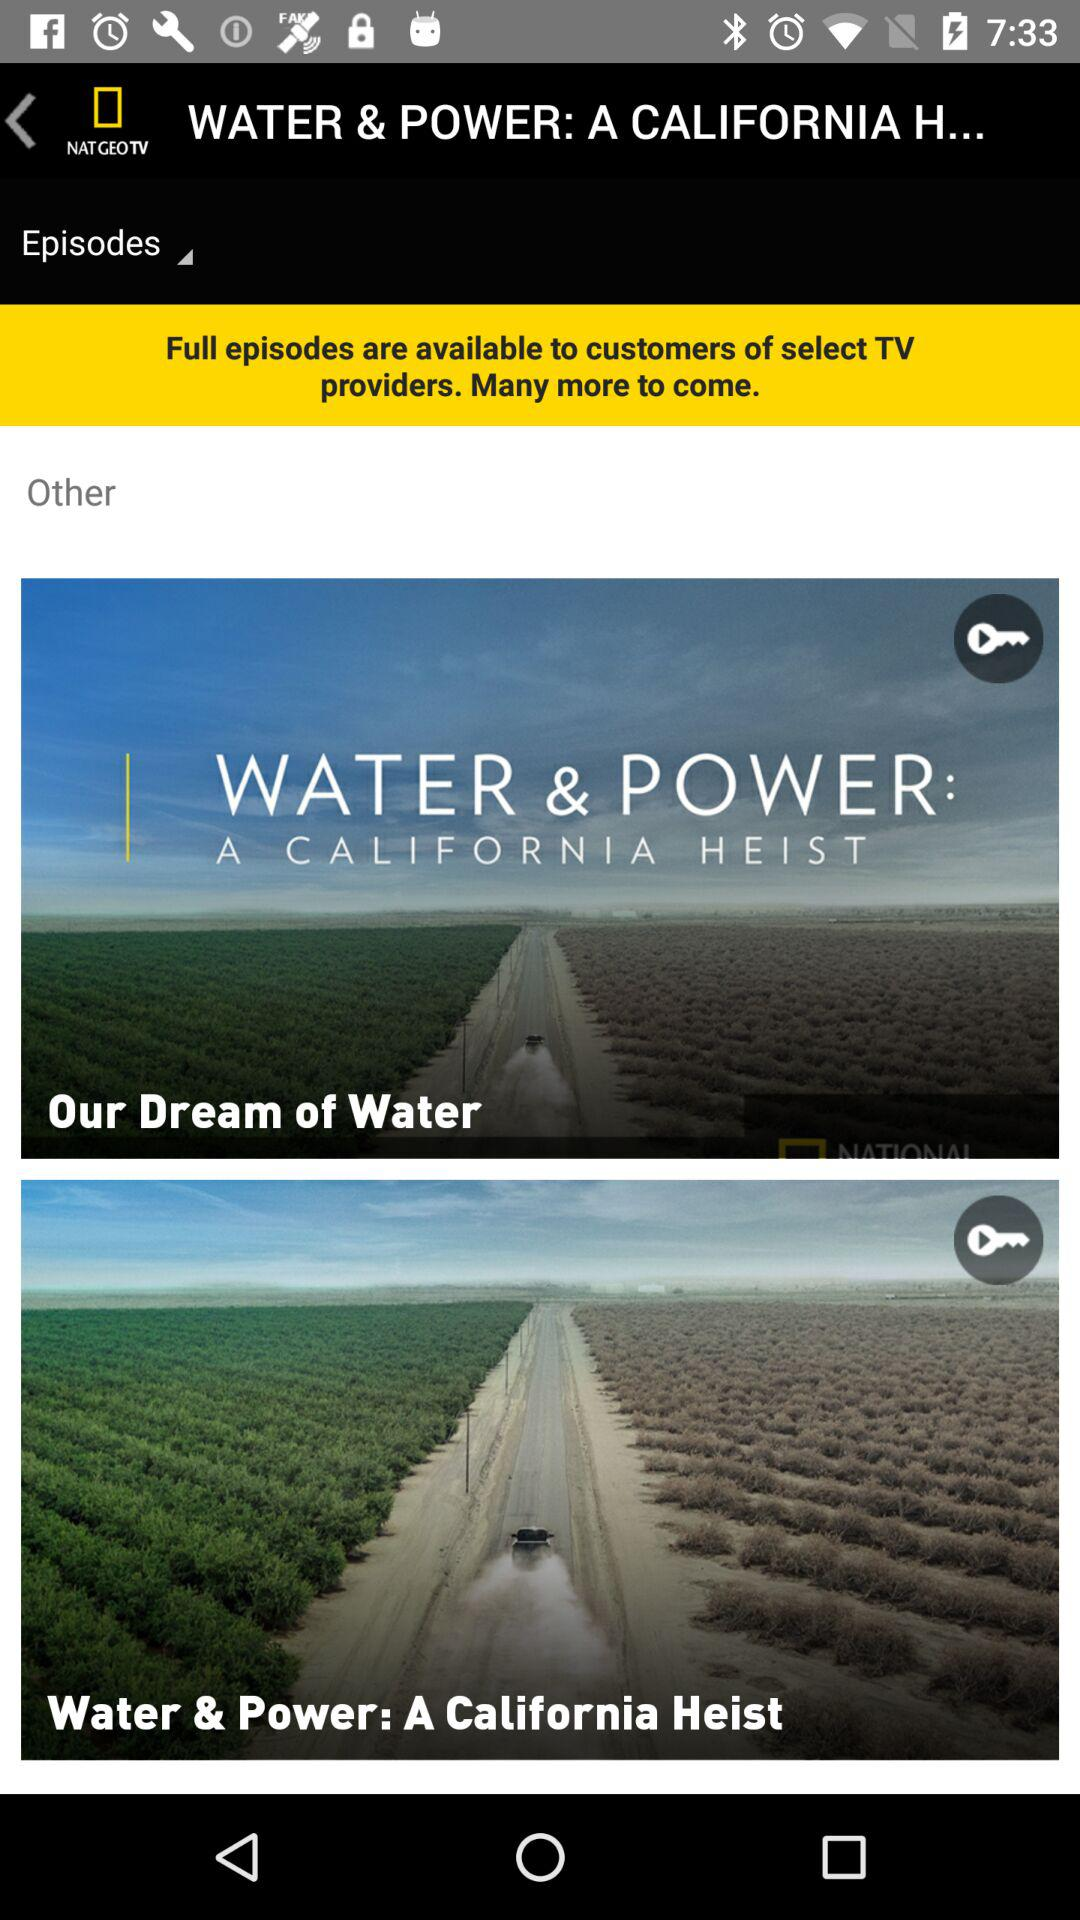How many episodes are available?
Answer the question using a single word or phrase. 2 